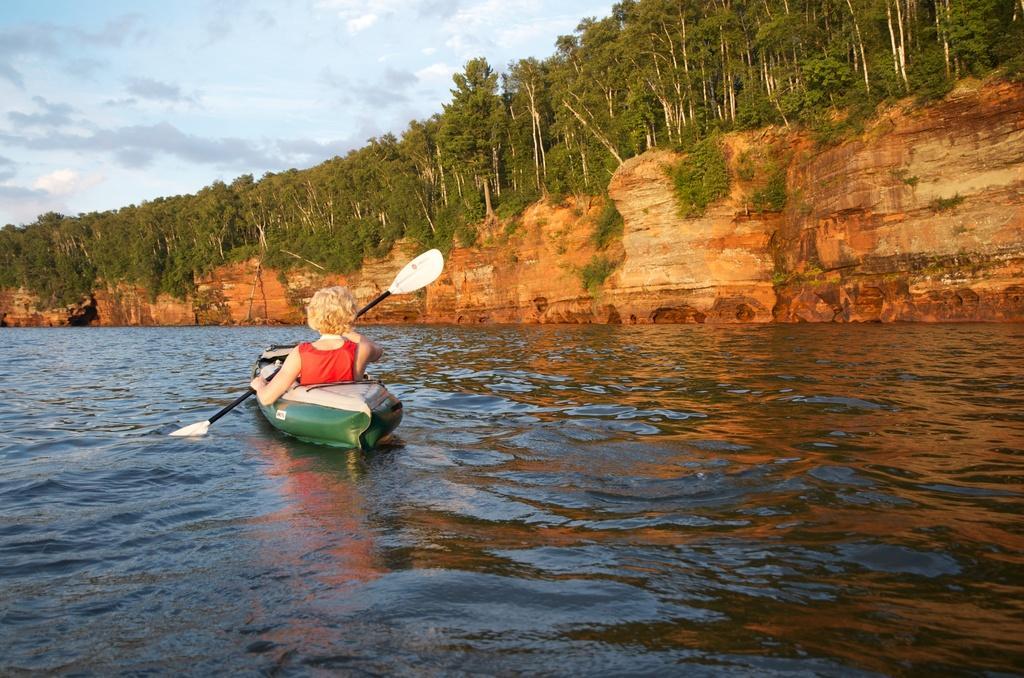Could you give a brief overview of what you see in this image? In this image we can see a person holding an object and sailing in the boat which is on the surface of the water. In the background we can see many trees. We can also see the sky with the clouds. We can also see the rock. 